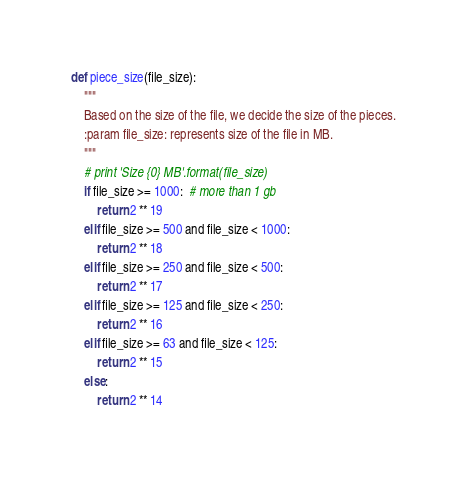Convert code to text. <code><loc_0><loc_0><loc_500><loc_500><_Python_>def piece_size(file_size):
    """
    Based on the size of the file, we decide the size of the pieces.
    :param file_size: represents size of the file in MB.
    """
    # print 'Size {0} MB'.format(file_size)
    if file_size >= 1000:  # more than 1 gb
        return 2 ** 19
    elif file_size >= 500 and file_size < 1000:
        return 2 ** 18
    elif file_size >= 250 and file_size < 500:
        return 2 ** 17
    elif file_size >= 125 and file_size < 250:
        return 2 ** 16
    elif file_size >= 63 and file_size < 125:
        return 2 ** 15
    else:
        return 2 ** 14
</code> 